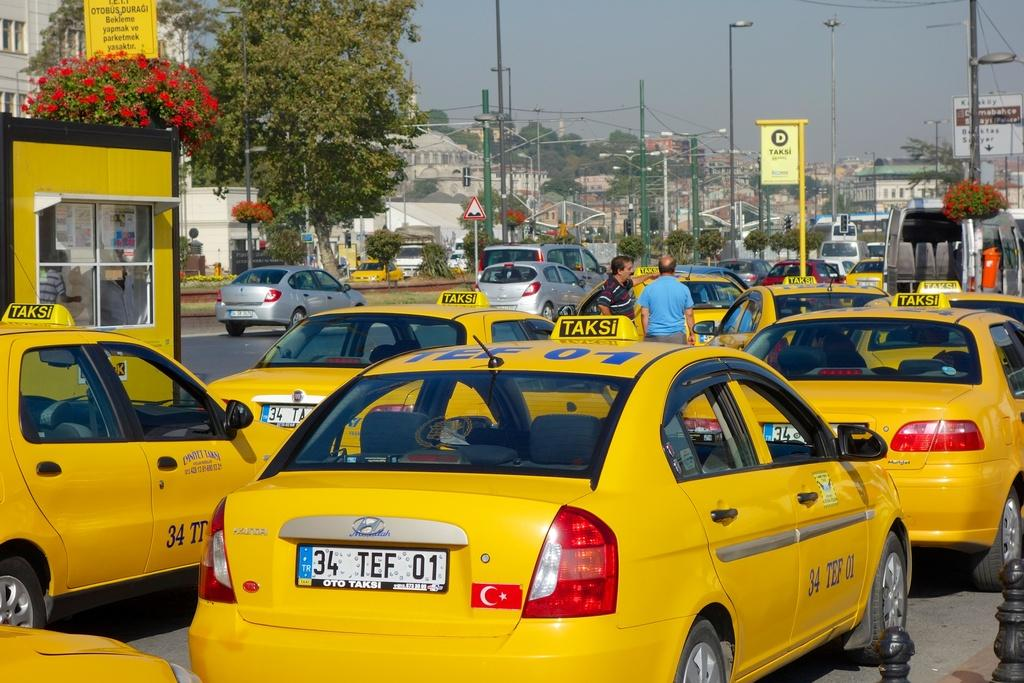<image>
Describe the image concisely. some taxis with one that has the letter 34 on it 